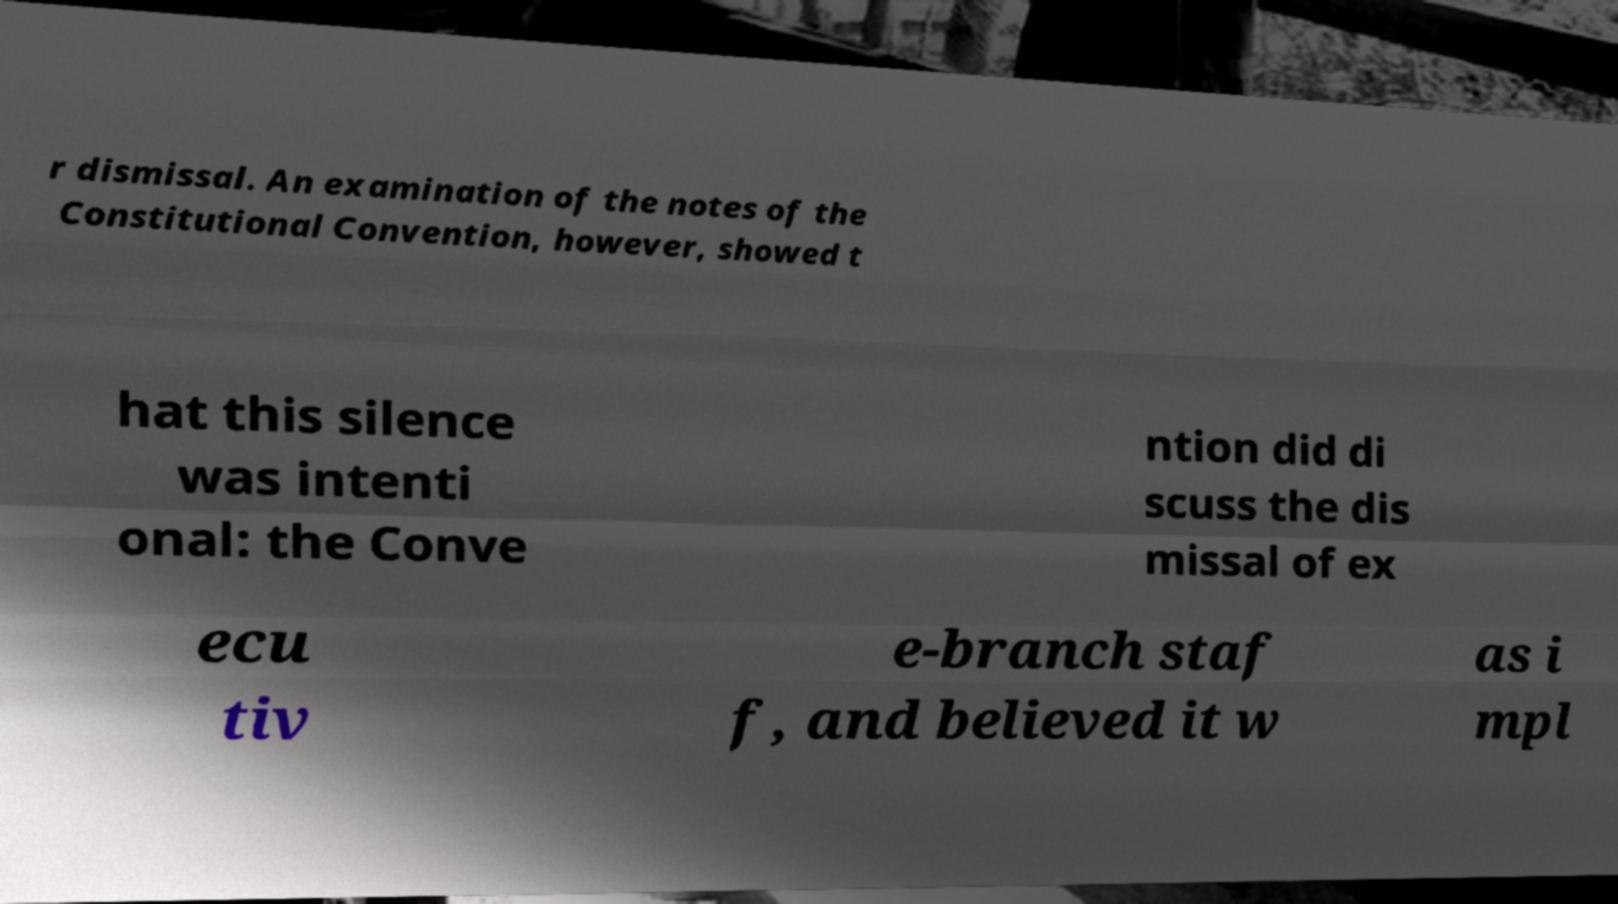For documentation purposes, I need the text within this image transcribed. Could you provide that? r dismissal. An examination of the notes of the Constitutional Convention, however, showed t hat this silence was intenti onal: the Conve ntion did di scuss the dis missal of ex ecu tiv e-branch staf f, and believed it w as i mpl 